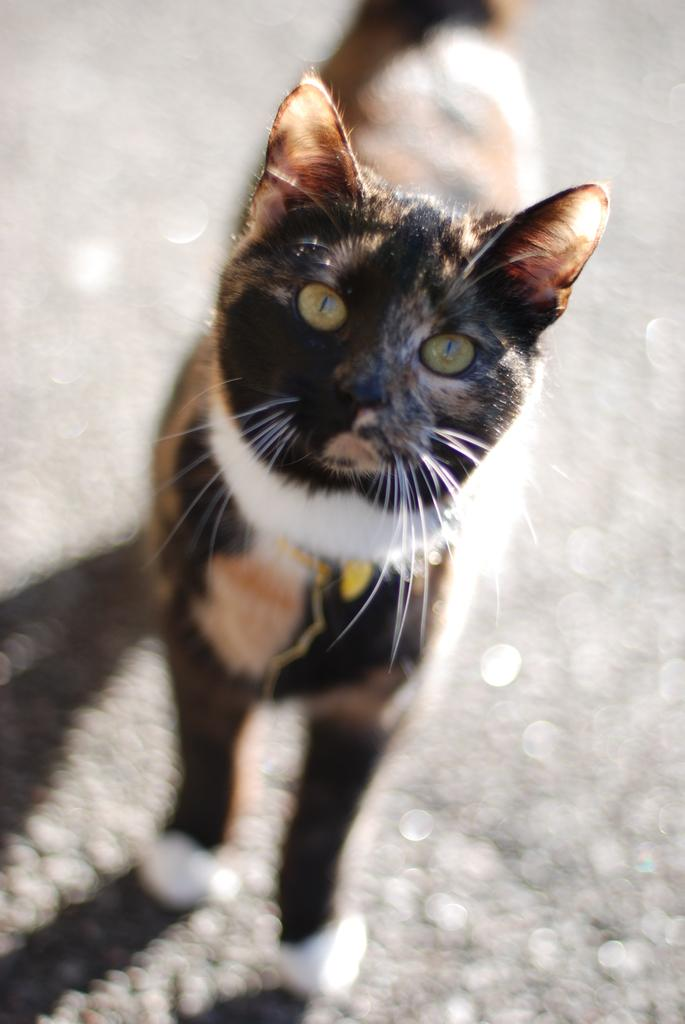What type of animal is in the image? There is a cat in the image. What is the cat doing in the image? The cat is standing. What colors can be seen on the cat? The cat is in brown, black, and white colors. Can you describe the man at the bottom of the image? The transcript is unclear about the man's role or relationship to the cat. What type of structure can be seen in the bedroom in the image? There is no bedroom or structure present in the image; it features a cat standing in brown, black, and white colors. 